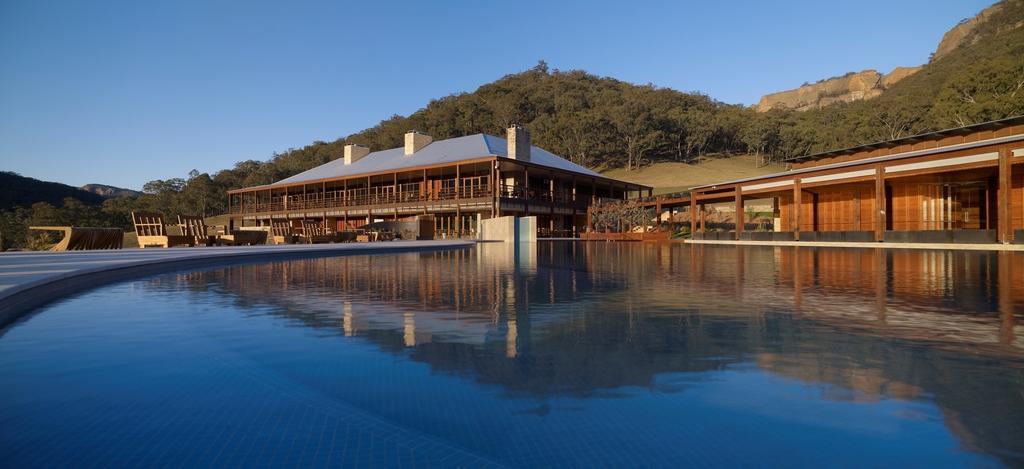Describe this image in one or two sentences. In this image I can see the water, the ground, few benches and few buildings. In the background I can see few mountains, few trees and the sky. 